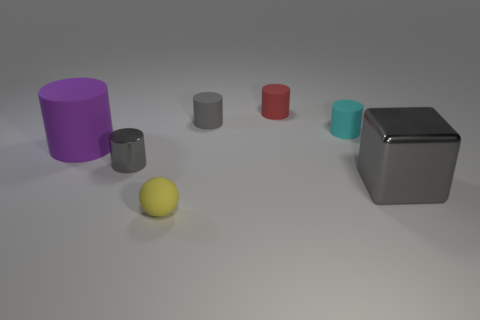Are there the same number of large purple cylinders that are behind the tiny red matte thing and small metallic objects that are left of the small gray metal object?
Make the answer very short. Yes. Does the tiny matte object in front of the big matte thing have the same shape as the gray object to the right of the gray matte cylinder?
Offer a very short reply. No. Are there any other things that are the same shape as the large purple object?
Provide a succinct answer. Yes. There is a big purple object that is the same material as the yellow object; what is its shape?
Ensure brevity in your answer.  Cylinder. Is the number of gray rubber cylinders on the left side of the small yellow matte thing the same as the number of small gray objects?
Offer a very short reply. No. Does the small gray cylinder in front of the tiny gray rubber cylinder have the same material as the large thing that is to the right of the purple rubber thing?
Provide a short and direct response. Yes. The rubber thing that is to the left of the small matte thing in front of the large gray metallic block is what shape?
Offer a very short reply. Cylinder. There is a big cylinder that is made of the same material as the small sphere; what is its color?
Offer a very short reply. Purple. Is the number of tiny yellow rubber cylinders the same as the number of rubber things?
Ensure brevity in your answer.  No. Do the tiny sphere and the tiny metallic thing have the same color?
Offer a terse response. No. 